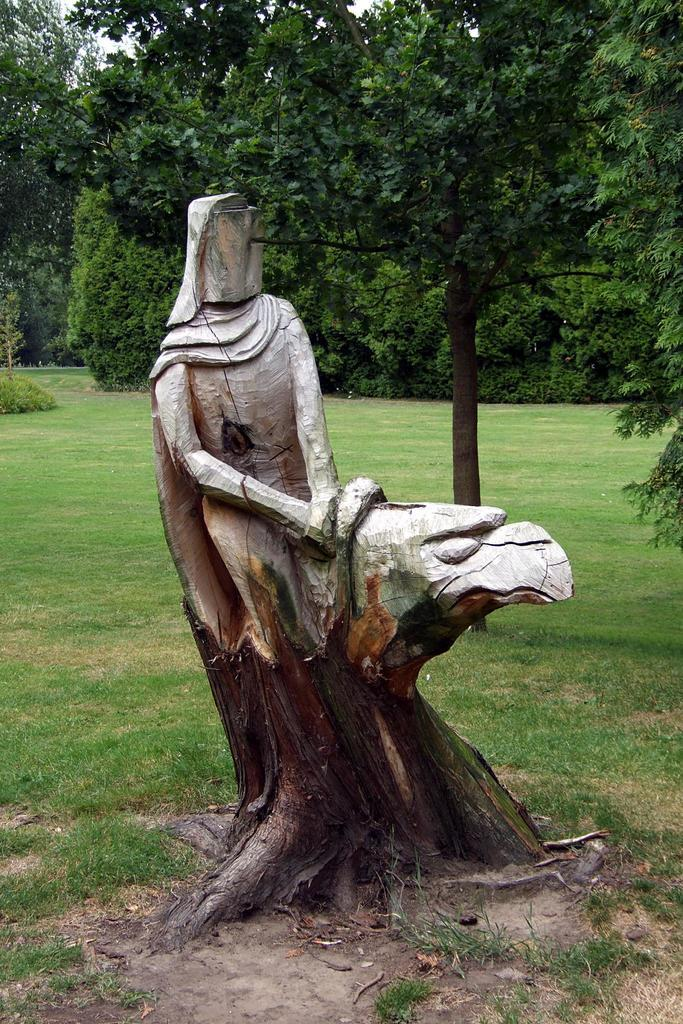What type of artwork is featured in the image? There is a wood sculpture in the image. What is the terrain like in the image? The land is covered with grass. What can be seen in the background of the image? There are trees in the background of the image. How many fish can be seen swimming in the grass in the image? There are no fish visible in the image; the land is covered with grass. 